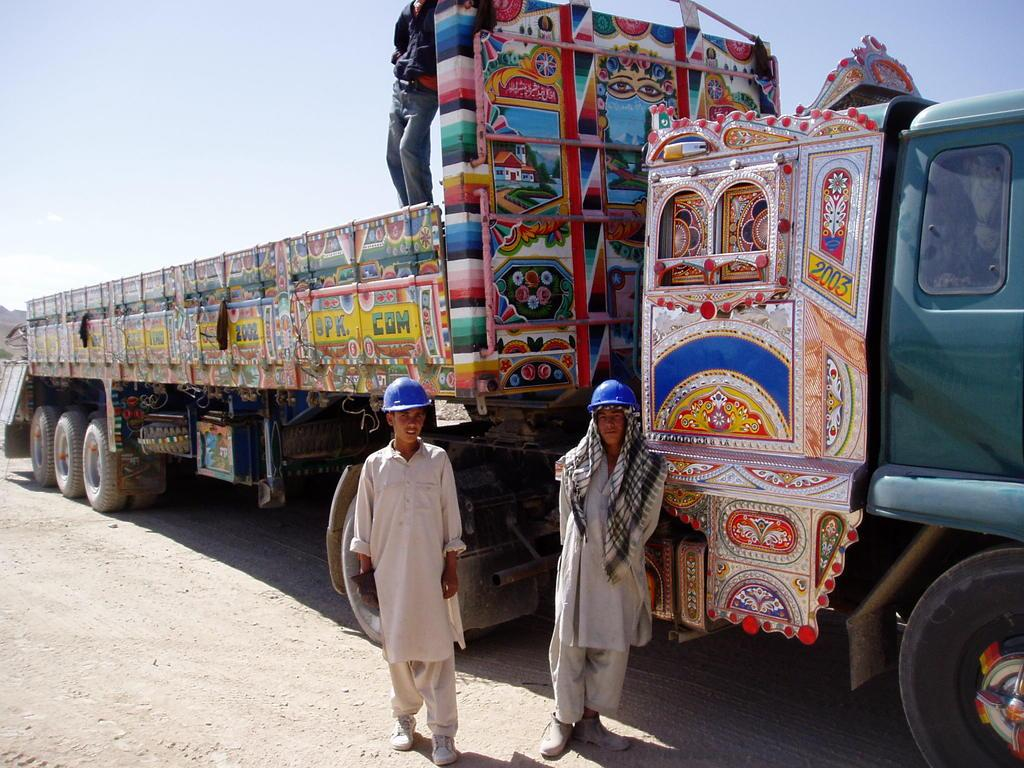What is the main subject in the image? There is a vehicle in the image. Can you describe the people in the image? Two people are standing in the image, and they are wearing blue color helmets. What can be seen in the background of the image? The sky is visible in the image. What is the color of the sky in the image? The color of the sky is white. What type of collar can be seen on the vehicle in the image? There is no collar present on the vehicle in the image. Who is the manager of the people in the image? The image does not provide any information about a manager or any organizational hierarchy. 